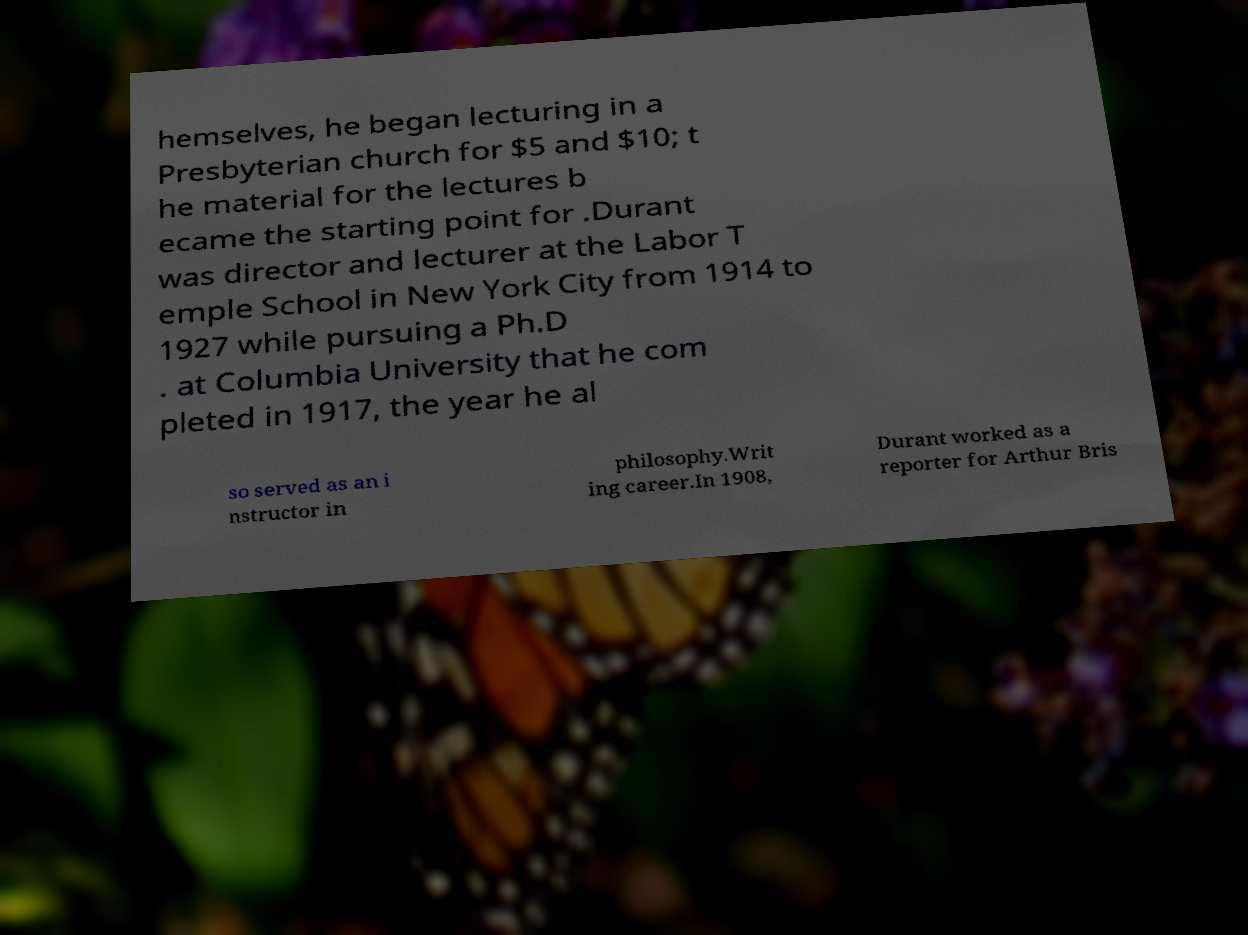Can you read and provide the text displayed in the image?This photo seems to have some interesting text. Can you extract and type it out for me? hemselves, he began lecturing in a Presbyterian church for $5 and $10; t he material for the lectures b ecame the starting point for .Durant was director and lecturer at the Labor T emple School in New York City from 1914 to 1927 while pursuing a Ph.D . at Columbia University that he com pleted in 1917, the year he al so served as an i nstructor in philosophy.Writ ing career.In 1908, Durant worked as a reporter for Arthur Bris 